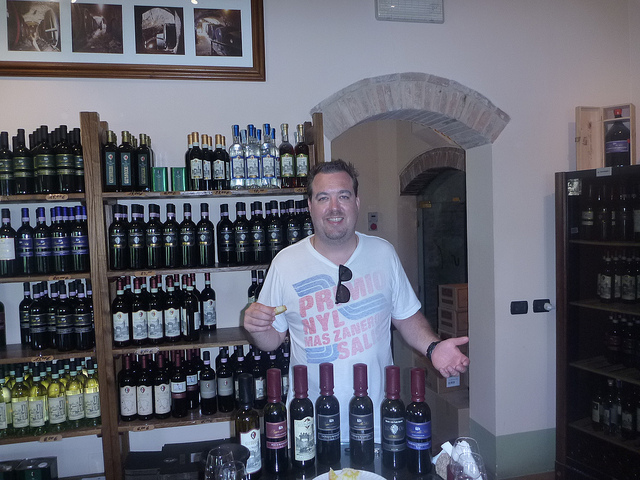Extract all visible text content from this image. PRAMID NYL SALE MAS ZAMBER 